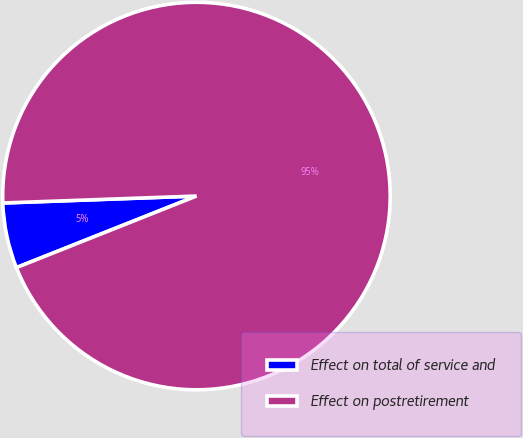Convert chart. <chart><loc_0><loc_0><loc_500><loc_500><pie_chart><fcel>Effect on total of service and<fcel>Effect on postretirement<nl><fcel>5.45%<fcel>94.55%<nl></chart> 